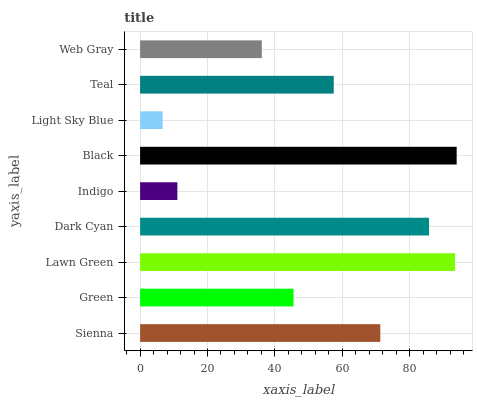Is Light Sky Blue the minimum?
Answer yes or no. Yes. Is Black the maximum?
Answer yes or no. Yes. Is Green the minimum?
Answer yes or no. No. Is Green the maximum?
Answer yes or no. No. Is Sienna greater than Green?
Answer yes or no. Yes. Is Green less than Sienna?
Answer yes or no. Yes. Is Green greater than Sienna?
Answer yes or no. No. Is Sienna less than Green?
Answer yes or no. No. Is Teal the high median?
Answer yes or no. Yes. Is Teal the low median?
Answer yes or no. Yes. Is Black the high median?
Answer yes or no. No. Is Dark Cyan the low median?
Answer yes or no. No. 